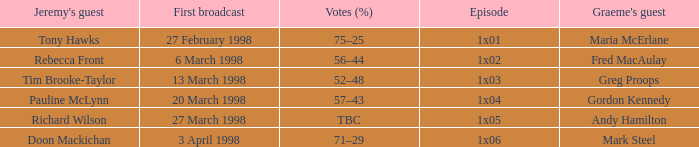What is Jeremy's Guest, when First Broadcast is "20 March 1998"? Pauline McLynn. 